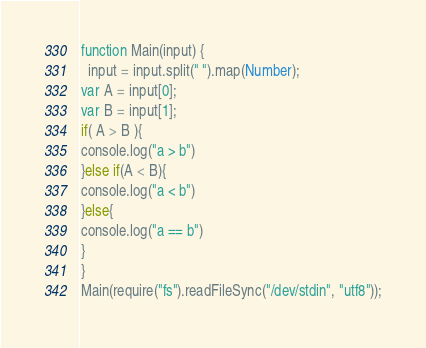<code> <loc_0><loc_0><loc_500><loc_500><_JavaScript_>function Main(input) {
  input = input.split(" ").map(Number);
var A = input[0];
var B = input[1];
if( A > B ){
console.log("a > b")
}else if(A < B){
console.log("a < b")
}else{
console.log("a == b")
}
}
Main(require("fs").readFileSync("/dev/stdin", "utf8"));
</code> 